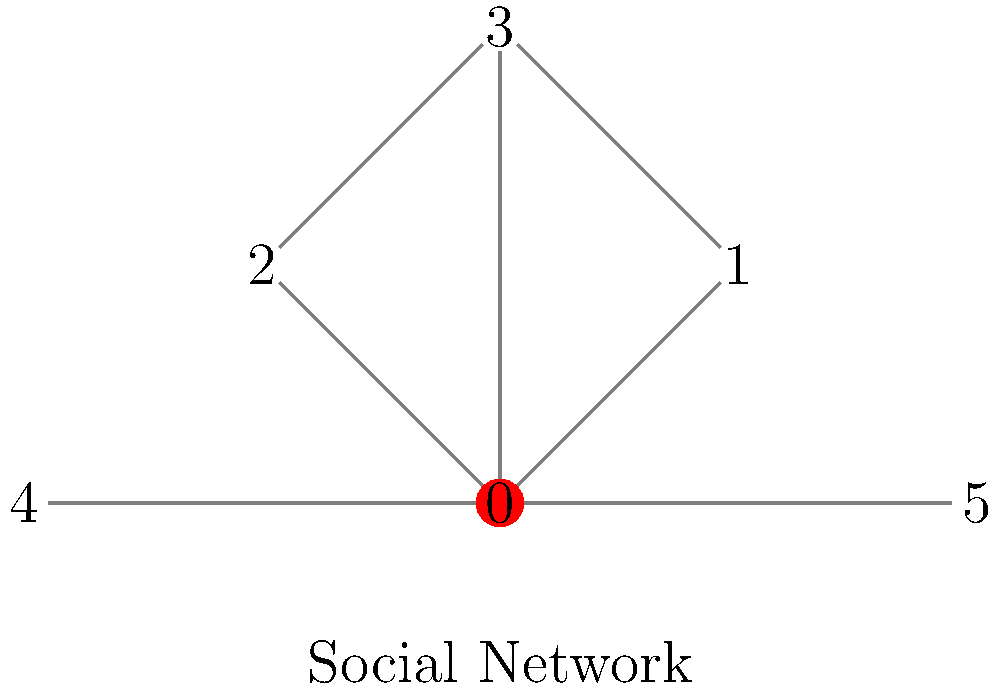In the social network graph shown above, which node has the highest degree centrality, and how might this relate to its potential influence on societal change? To answer this question, we need to follow these steps:

1. Understand degree centrality:
   Degree centrality is a measure of the number of direct connections a node has in a network.

2. Count the connections for each node:
   Node 0: 5 connections
   Node 1: 2 connections
   Node 2: 2 connections
   Node 3: 3 connections
   Node 4: 2 connections
   Node 5: 2 connections

3. Identify the node with the highest degree centrality:
   Node 0 has the highest degree centrality with 5 connections.

4. Interpret the significance in terms of societal change:
   A node with high degree centrality often represents an individual or entity with many direct connections in a social network. This position can be influential for several reasons:

   a) Information dissemination: They can quickly spread information to many others.
   b) Opinion leadership: They may have more opportunities to influence others' views.
   c) Resource access: They can potentially mobilize more people for collective action.
   d) Bridge between communities: They might connect different subgroups within the network.

5. Relate to the debate of tradition vs. progress:
   The central node (0) could represent a key figure in driving societal change. Their extensive connections allow them to challenge traditional views and promote progressive ideas more effectively. However, it's important to note that having many connections doesn't guarantee influence; the quality and nature of these relationships also matter.
Answer: Node 0; highest potential for information dissemination and opinion leadership 